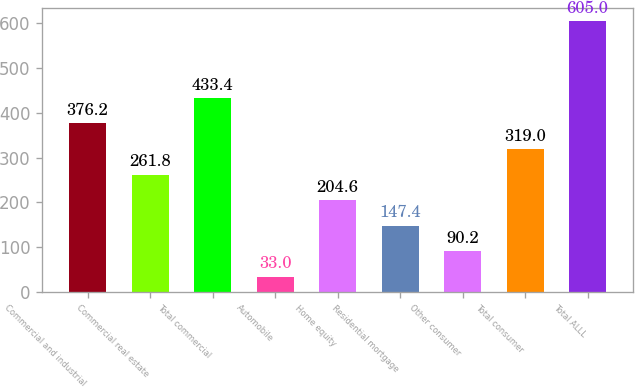Convert chart. <chart><loc_0><loc_0><loc_500><loc_500><bar_chart><fcel>Commercial and industrial<fcel>Commercial real estate<fcel>Total commercial<fcel>Automobile<fcel>Home equity<fcel>Residential mortgage<fcel>Other consumer<fcel>Total consumer<fcel>Total ALLL<nl><fcel>376.2<fcel>261.8<fcel>433.4<fcel>33<fcel>204.6<fcel>147.4<fcel>90.2<fcel>319<fcel>605<nl></chart> 